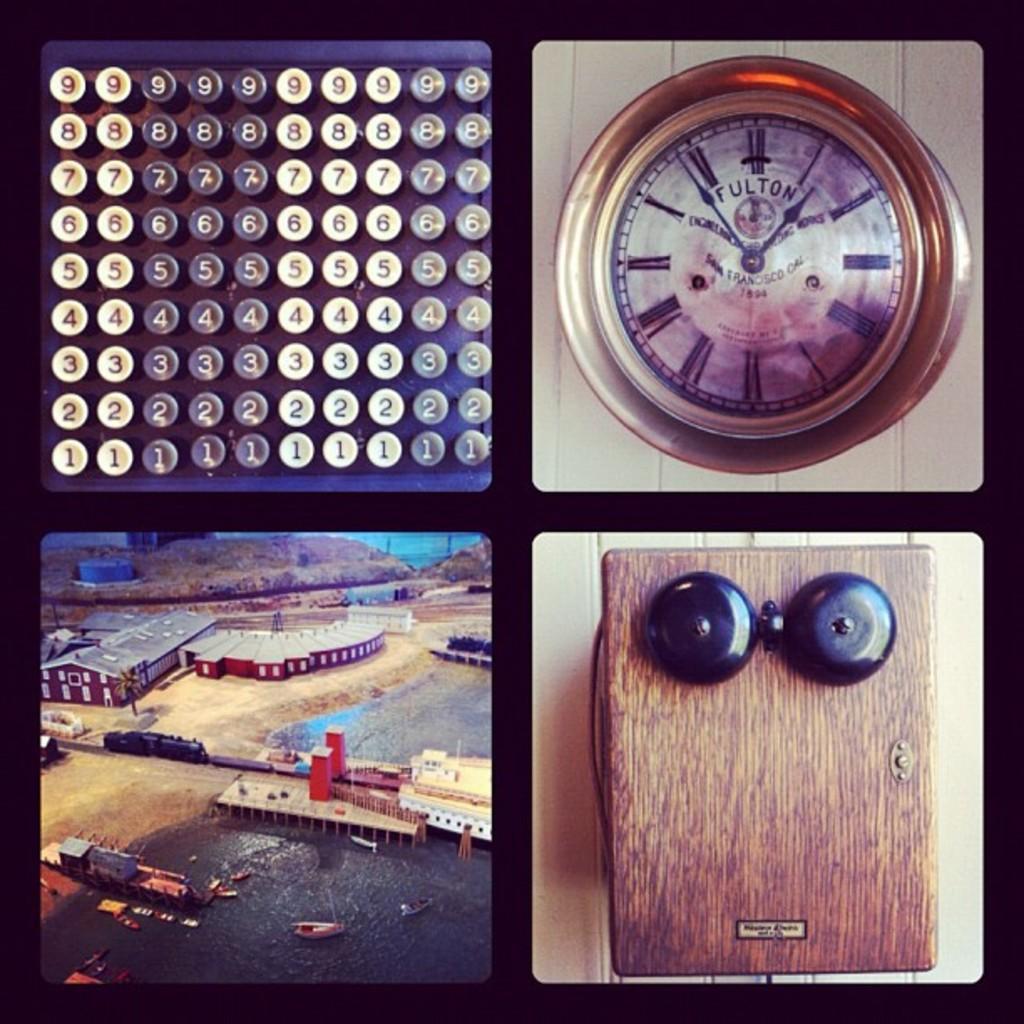In one or two sentences, can you explain what this image depicts? This is a collage image. In the first image, those are looking like number keys and in the second image there is a clock. In the third image there are buildings, piers, a train, some objects and boats on the water. In the fourth image there are black items on a wooden object. 